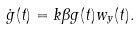<formula> <loc_0><loc_0><loc_500><loc_500>\dot { g } ( t ) = k \beta g ( t ) w _ { y } ( t ) .</formula> 